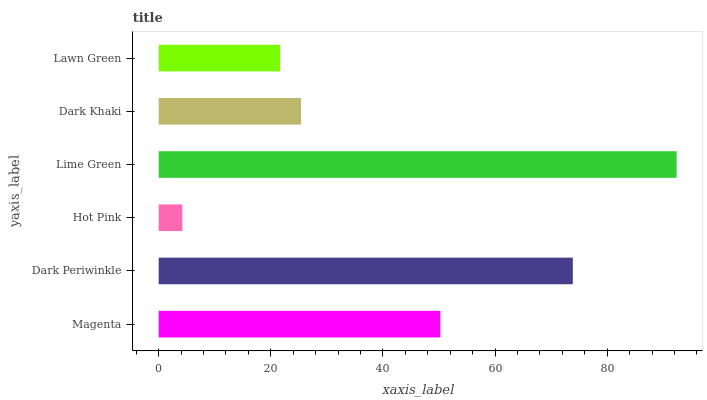Is Hot Pink the minimum?
Answer yes or no. Yes. Is Lime Green the maximum?
Answer yes or no. Yes. Is Dark Periwinkle the minimum?
Answer yes or no. No. Is Dark Periwinkle the maximum?
Answer yes or no. No. Is Dark Periwinkle greater than Magenta?
Answer yes or no. Yes. Is Magenta less than Dark Periwinkle?
Answer yes or no. Yes. Is Magenta greater than Dark Periwinkle?
Answer yes or no. No. Is Dark Periwinkle less than Magenta?
Answer yes or no. No. Is Magenta the high median?
Answer yes or no. Yes. Is Dark Khaki the low median?
Answer yes or no. Yes. Is Dark Periwinkle the high median?
Answer yes or no. No. Is Magenta the low median?
Answer yes or no. No. 